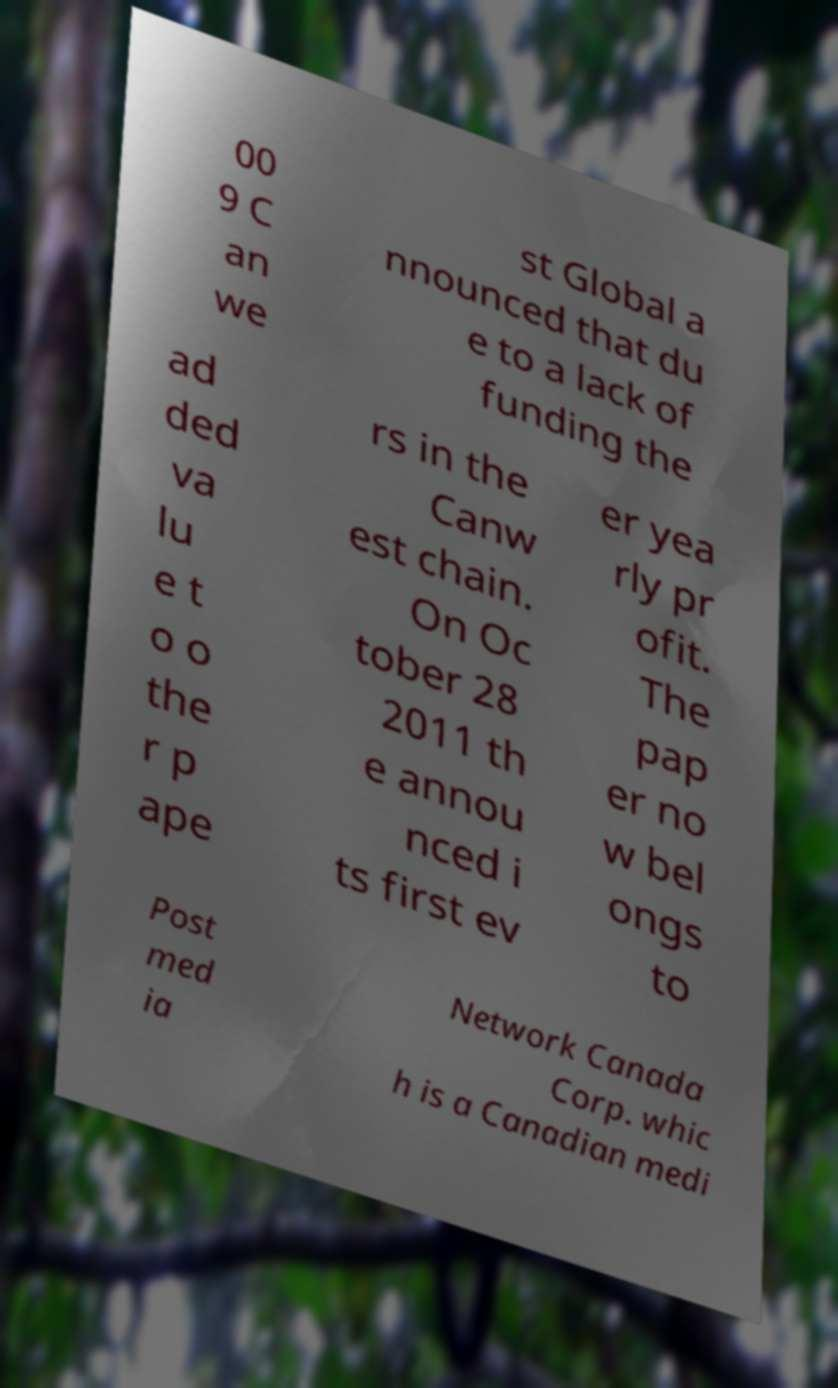Please read and relay the text visible in this image. What does it say? 00 9 C an we st Global a nnounced that du e to a lack of funding the ad ded va lu e t o o the r p ape rs in the Canw est chain. On Oc tober 28 2011 th e annou nced i ts first ev er yea rly pr ofit. The pap er no w bel ongs to Post med ia Network Canada Corp. whic h is a Canadian medi 